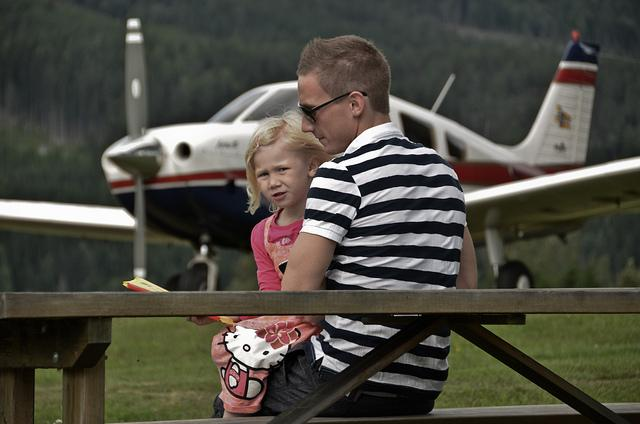What is the thing on the front tip of the airplane? propeller 